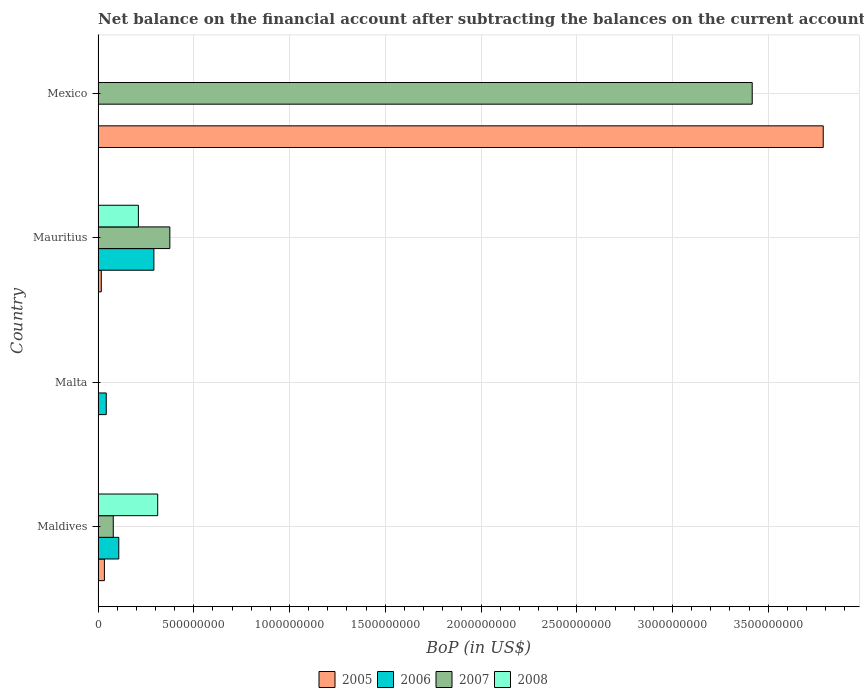How many different coloured bars are there?
Your response must be concise. 4. Are the number of bars per tick equal to the number of legend labels?
Ensure brevity in your answer.  No. Are the number of bars on each tick of the Y-axis equal?
Make the answer very short. No. How many bars are there on the 4th tick from the top?
Offer a terse response. 4. How many bars are there on the 1st tick from the bottom?
Offer a terse response. 4. What is the label of the 1st group of bars from the top?
Your response must be concise. Mexico. In how many cases, is the number of bars for a given country not equal to the number of legend labels?
Keep it short and to the point. 2. What is the Balance of Payments in 2005 in Maldives?
Ensure brevity in your answer.  3.32e+07. Across all countries, what is the maximum Balance of Payments in 2007?
Your response must be concise. 3.42e+09. Across all countries, what is the minimum Balance of Payments in 2008?
Provide a short and direct response. 0. In which country was the Balance of Payments in 2006 maximum?
Ensure brevity in your answer.  Mauritius. What is the total Balance of Payments in 2006 in the graph?
Give a very brief answer. 4.43e+08. What is the difference between the Balance of Payments in 2005 in Maldives and that in Mauritius?
Your answer should be very brief. 1.62e+07. What is the difference between the Balance of Payments in 2007 in Maldives and the Balance of Payments in 2008 in Malta?
Offer a terse response. 7.95e+07. What is the average Balance of Payments in 2008 per country?
Provide a short and direct response. 1.31e+08. What is the difference between the Balance of Payments in 2006 and Balance of Payments in 2008 in Mauritius?
Your answer should be very brief. 8.10e+07. What is the ratio of the Balance of Payments in 2005 in Maldives to that in Mexico?
Your answer should be compact. 0.01. What is the difference between the highest and the second highest Balance of Payments in 2005?
Provide a short and direct response. 3.75e+09. What is the difference between the highest and the lowest Balance of Payments in 2006?
Keep it short and to the point. 2.92e+08. In how many countries, is the Balance of Payments in 2008 greater than the average Balance of Payments in 2008 taken over all countries?
Give a very brief answer. 2. Is it the case that in every country, the sum of the Balance of Payments in 2006 and Balance of Payments in 2007 is greater than the sum of Balance of Payments in 2005 and Balance of Payments in 2008?
Provide a short and direct response. No. Is it the case that in every country, the sum of the Balance of Payments in 2006 and Balance of Payments in 2008 is greater than the Balance of Payments in 2005?
Ensure brevity in your answer.  No. Are the values on the major ticks of X-axis written in scientific E-notation?
Ensure brevity in your answer.  No. Where does the legend appear in the graph?
Offer a terse response. Bottom center. What is the title of the graph?
Provide a succinct answer. Net balance on the financial account after subtracting the balances on the current accounts. Does "2000" appear as one of the legend labels in the graph?
Offer a terse response. No. What is the label or title of the X-axis?
Offer a very short reply. BoP (in US$). What is the label or title of the Y-axis?
Ensure brevity in your answer.  Country. What is the BoP (in US$) in 2005 in Maldives?
Make the answer very short. 3.32e+07. What is the BoP (in US$) of 2006 in Maldives?
Your response must be concise. 1.08e+08. What is the BoP (in US$) in 2007 in Maldives?
Keep it short and to the point. 7.95e+07. What is the BoP (in US$) of 2008 in Maldives?
Give a very brief answer. 3.11e+08. What is the BoP (in US$) in 2006 in Malta?
Provide a short and direct response. 4.28e+07. What is the BoP (in US$) in 2007 in Malta?
Your response must be concise. 0. What is the BoP (in US$) of 2008 in Malta?
Give a very brief answer. 0. What is the BoP (in US$) in 2005 in Mauritius?
Offer a terse response. 1.69e+07. What is the BoP (in US$) in 2006 in Mauritius?
Your answer should be compact. 2.92e+08. What is the BoP (in US$) in 2007 in Mauritius?
Ensure brevity in your answer.  3.75e+08. What is the BoP (in US$) in 2008 in Mauritius?
Offer a very short reply. 2.11e+08. What is the BoP (in US$) of 2005 in Mexico?
Keep it short and to the point. 3.79e+09. What is the BoP (in US$) of 2007 in Mexico?
Provide a succinct answer. 3.42e+09. Across all countries, what is the maximum BoP (in US$) in 2005?
Your answer should be compact. 3.79e+09. Across all countries, what is the maximum BoP (in US$) in 2006?
Your response must be concise. 2.92e+08. Across all countries, what is the maximum BoP (in US$) of 2007?
Your answer should be very brief. 3.42e+09. Across all countries, what is the maximum BoP (in US$) of 2008?
Give a very brief answer. 3.11e+08. Across all countries, what is the minimum BoP (in US$) of 2005?
Your answer should be compact. 0. Across all countries, what is the minimum BoP (in US$) in 2008?
Your answer should be compact. 0. What is the total BoP (in US$) of 2005 in the graph?
Ensure brevity in your answer.  3.84e+09. What is the total BoP (in US$) of 2006 in the graph?
Your answer should be very brief. 4.43e+08. What is the total BoP (in US$) of 2007 in the graph?
Provide a short and direct response. 3.87e+09. What is the total BoP (in US$) in 2008 in the graph?
Ensure brevity in your answer.  5.22e+08. What is the difference between the BoP (in US$) in 2006 in Maldives and that in Malta?
Make the answer very short. 6.54e+07. What is the difference between the BoP (in US$) of 2005 in Maldives and that in Mauritius?
Keep it short and to the point. 1.62e+07. What is the difference between the BoP (in US$) of 2006 in Maldives and that in Mauritius?
Your response must be concise. -1.83e+08. What is the difference between the BoP (in US$) in 2007 in Maldives and that in Mauritius?
Offer a terse response. -2.95e+08. What is the difference between the BoP (in US$) of 2008 in Maldives and that in Mauritius?
Give a very brief answer. 1.01e+08. What is the difference between the BoP (in US$) in 2005 in Maldives and that in Mexico?
Offer a terse response. -3.75e+09. What is the difference between the BoP (in US$) in 2007 in Maldives and that in Mexico?
Offer a terse response. -3.34e+09. What is the difference between the BoP (in US$) of 2006 in Malta and that in Mauritius?
Keep it short and to the point. -2.49e+08. What is the difference between the BoP (in US$) in 2005 in Mauritius and that in Mexico?
Keep it short and to the point. -3.77e+09. What is the difference between the BoP (in US$) in 2007 in Mauritius and that in Mexico?
Offer a very short reply. -3.04e+09. What is the difference between the BoP (in US$) of 2005 in Maldives and the BoP (in US$) of 2006 in Malta?
Give a very brief answer. -9.65e+06. What is the difference between the BoP (in US$) of 2005 in Maldives and the BoP (in US$) of 2006 in Mauritius?
Your response must be concise. -2.58e+08. What is the difference between the BoP (in US$) of 2005 in Maldives and the BoP (in US$) of 2007 in Mauritius?
Provide a succinct answer. -3.42e+08. What is the difference between the BoP (in US$) of 2005 in Maldives and the BoP (in US$) of 2008 in Mauritius?
Make the answer very short. -1.78e+08. What is the difference between the BoP (in US$) in 2006 in Maldives and the BoP (in US$) in 2007 in Mauritius?
Keep it short and to the point. -2.67e+08. What is the difference between the BoP (in US$) in 2006 in Maldives and the BoP (in US$) in 2008 in Mauritius?
Ensure brevity in your answer.  -1.02e+08. What is the difference between the BoP (in US$) in 2007 in Maldives and the BoP (in US$) in 2008 in Mauritius?
Offer a terse response. -1.31e+08. What is the difference between the BoP (in US$) in 2005 in Maldives and the BoP (in US$) in 2007 in Mexico?
Give a very brief answer. -3.38e+09. What is the difference between the BoP (in US$) of 2006 in Maldives and the BoP (in US$) of 2007 in Mexico?
Make the answer very short. -3.31e+09. What is the difference between the BoP (in US$) in 2006 in Malta and the BoP (in US$) in 2007 in Mauritius?
Your response must be concise. -3.32e+08. What is the difference between the BoP (in US$) of 2006 in Malta and the BoP (in US$) of 2008 in Mauritius?
Keep it short and to the point. -1.68e+08. What is the difference between the BoP (in US$) of 2006 in Malta and the BoP (in US$) of 2007 in Mexico?
Offer a terse response. -3.37e+09. What is the difference between the BoP (in US$) in 2005 in Mauritius and the BoP (in US$) in 2007 in Mexico?
Offer a terse response. -3.40e+09. What is the difference between the BoP (in US$) of 2006 in Mauritius and the BoP (in US$) of 2007 in Mexico?
Your answer should be very brief. -3.12e+09. What is the average BoP (in US$) of 2005 per country?
Keep it short and to the point. 9.59e+08. What is the average BoP (in US$) in 2006 per country?
Ensure brevity in your answer.  1.11e+08. What is the average BoP (in US$) in 2007 per country?
Give a very brief answer. 9.68e+08. What is the average BoP (in US$) in 2008 per country?
Provide a short and direct response. 1.31e+08. What is the difference between the BoP (in US$) in 2005 and BoP (in US$) in 2006 in Maldives?
Keep it short and to the point. -7.51e+07. What is the difference between the BoP (in US$) in 2005 and BoP (in US$) in 2007 in Maldives?
Ensure brevity in your answer.  -4.63e+07. What is the difference between the BoP (in US$) of 2005 and BoP (in US$) of 2008 in Maldives?
Provide a succinct answer. -2.78e+08. What is the difference between the BoP (in US$) in 2006 and BoP (in US$) in 2007 in Maldives?
Provide a succinct answer. 2.88e+07. What is the difference between the BoP (in US$) in 2006 and BoP (in US$) in 2008 in Maldives?
Provide a succinct answer. -2.03e+08. What is the difference between the BoP (in US$) in 2007 and BoP (in US$) in 2008 in Maldives?
Ensure brevity in your answer.  -2.32e+08. What is the difference between the BoP (in US$) in 2005 and BoP (in US$) in 2006 in Mauritius?
Ensure brevity in your answer.  -2.75e+08. What is the difference between the BoP (in US$) of 2005 and BoP (in US$) of 2007 in Mauritius?
Your answer should be compact. -3.58e+08. What is the difference between the BoP (in US$) of 2005 and BoP (in US$) of 2008 in Mauritius?
Provide a short and direct response. -1.94e+08. What is the difference between the BoP (in US$) in 2006 and BoP (in US$) in 2007 in Mauritius?
Offer a terse response. -8.33e+07. What is the difference between the BoP (in US$) in 2006 and BoP (in US$) in 2008 in Mauritius?
Your answer should be very brief. 8.10e+07. What is the difference between the BoP (in US$) in 2007 and BoP (in US$) in 2008 in Mauritius?
Provide a short and direct response. 1.64e+08. What is the difference between the BoP (in US$) of 2005 and BoP (in US$) of 2007 in Mexico?
Your response must be concise. 3.71e+08. What is the ratio of the BoP (in US$) of 2006 in Maldives to that in Malta?
Provide a short and direct response. 2.53. What is the ratio of the BoP (in US$) in 2005 in Maldives to that in Mauritius?
Offer a terse response. 1.96. What is the ratio of the BoP (in US$) in 2006 in Maldives to that in Mauritius?
Give a very brief answer. 0.37. What is the ratio of the BoP (in US$) of 2007 in Maldives to that in Mauritius?
Provide a short and direct response. 0.21. What is the ratio of the BoP (in US$) of 2008 in Maldives to that in Mauritius?
Make the answer very short. 1.48. What is the ratio of the BoP (in US$) in 2005 in Maldives to that in Mexico?
Your answer should be very brief. 0.01. What is the ratio of the BoP (in US$) in 2007 in Maldives to that in Mexico?
Your response must be concise. 0.02. What is the ratio of the BoP (in US$) of 2006 in Malta to that in Mauritius?
Give a very brief answer. 0.15. What is the ratio of the BoP (in US$) in 2005 in Mauritius to that in Mexico?
Offer a very short reply. 0. What is the ratio of the BoP (in US$) in 2007 in Mauritius to that in Mexico?
Ensure brevity in your answer.  0.11. What is the difference between the highest and the second highest BoP (in US$) of 2005?
Provide a succinct answer. 3.75e+09. What is the difference between the highest and the second highest BoP (in US$) in 2006?
Provide a short and direct response. 1.83e+08. What is the difference between the highest and the second highest BoP (in US$) of 2007?
Make the answer very short. 3.04e+09. What is the difference between the highest and the lowest BoP (in US$) of 2005?
Provide a succinct answer. 3.79e+09. What is the difference between the highest and the lowest BoP (in US$) in 2006?
Offer a terse response. 2.92e+08. What is the difference between the highest and the lowest BoP (in US$) of 2007?
Offer a very short reply. 3.42e+09. What is the difference between the highest and the lowest BoP (in US$) in 2008?
Your answer should be compact. 3.11e+08. 